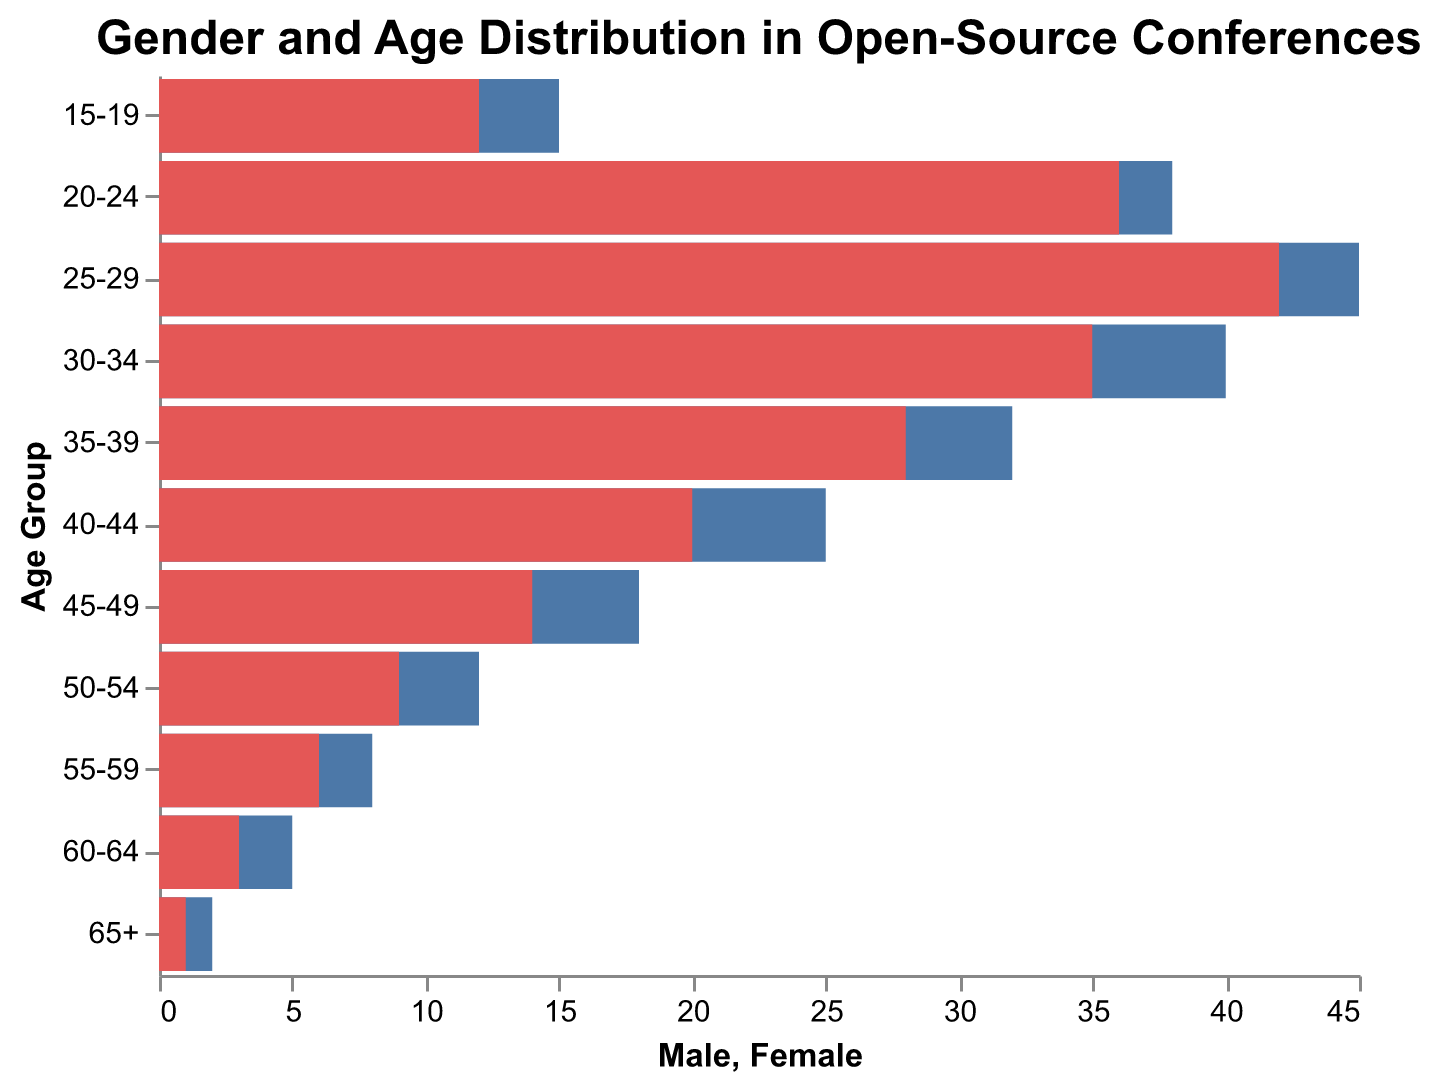What is the title of the figure? The title is displayed prominently at the top of the figure. It reads "Gender and Age Distribution in Open-Source Conferences".
Answer: Gender and Age Distribution in Open-Source Conferences Which age group has the highest number of male participants? By looking at the blue bars representing male participants, the longest bar corresponds to the 25-29 age group with 45 male participants.
Answer: 25-29 Are there more male or female participants in the 40-44 age group? By comparing the lengths of the blue bar for males (25) and the red bar for females (20) in the 40-44 age group, there are more male participants.
Answer: Male What's the difference in male and female participants in the 30-34 age group? The number of male participants is 40 and the female participants are 35. The difference is calculated as 40 - 35.
Answer: 5 What's the overall trend in the number of participants as the age group increases from 15-19 to 25-29? Observing both male and female bars, the trend shows an increase in participants up to the 25-29 age group.
Answer: Increase How many more male participants are there compared to female participants in the 20-24 age group? The number of male participants is 38 and female participants are 36. The difference is calculated as 38 - 36.
Answer: 2 Which age group has the smallest difference in male and female participants? By comparing the differences across all age groups, the 15-19 age group has the smallest difference with males being 15 and females being 12, resulting in a difference of 3.
Answer: 15-19 What pattern do you observe in the gender distribution as the age group increases? As age groups increase from youngest to oldest, the number of male and female participants generally decreases. Additionally, the number of males consistently exceeds the number of females.
Answer: Decrease, males > females In which age group do female participants make up the highest proportion relative to males? Reviewing each age group, the 30-34 age group has the closest numbers with males at 40 and females at 35, resulting in females comprising the highest relative proportion.
Answer: 30-34 What is the ratio of male to female participants in the 45-49 age group? The number of male participants is 18 and females are 14. The ratio is calculated as 18:14 or simplified to 9:7.
Answer: 9:7 